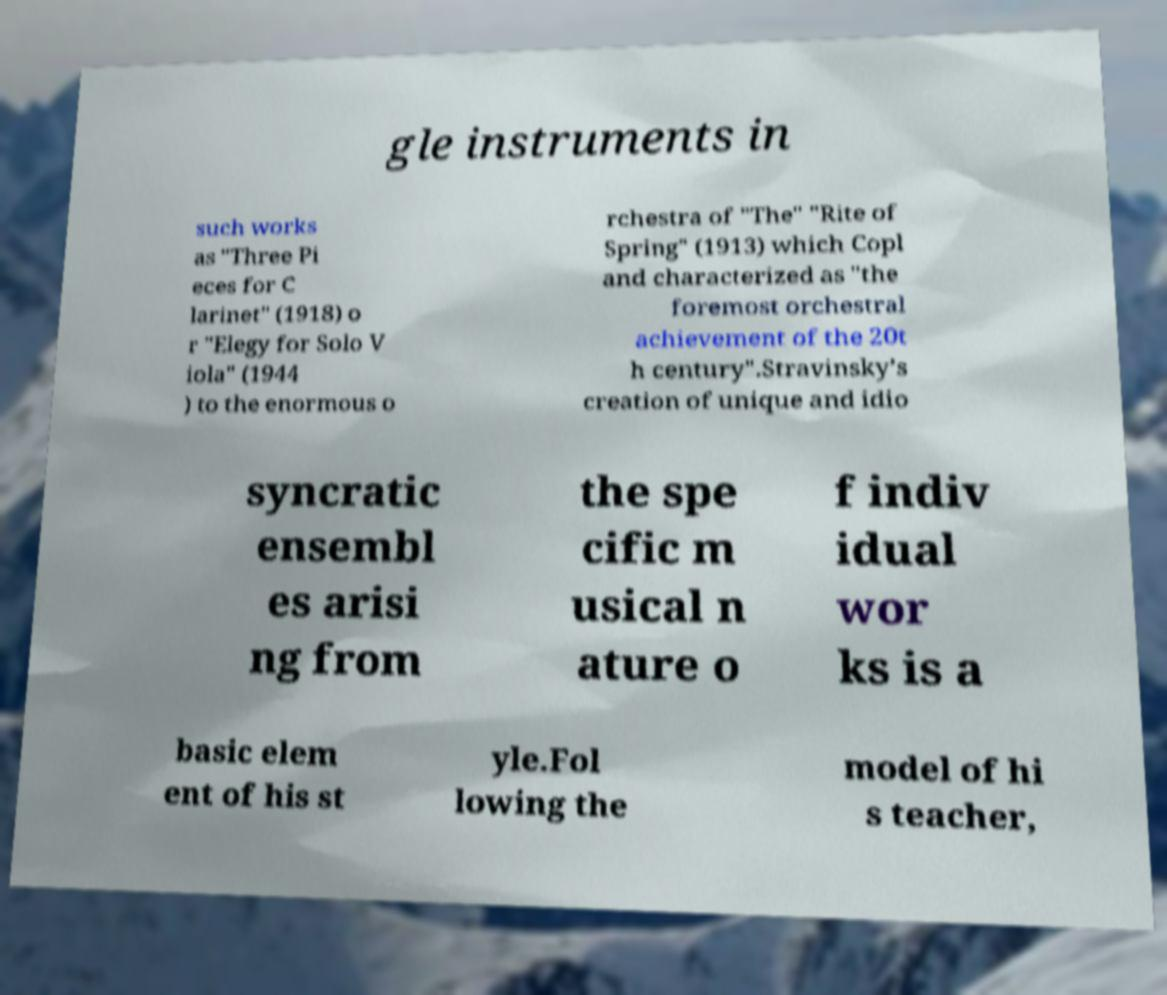Could you assist in decoding the text presented in this image and type it out clearly? gle instruments in such works as "Three Pi eces for C larinet" (1918) o r "Elegy for Solo V iola" (1944 ) to the enormous o rchestra of "The" "Rite of Spring" (1913) which Copl and characterized as "the foremost orchestral achievement of the 20t h century".Stravinsky’s creation of unique and idio syncratic ensembl es arisi ng from the spe cific m usical n ature o f indiv idual wor ks is a basic elem ent of his st yle.Fol lowing the model of hi s teacher, 